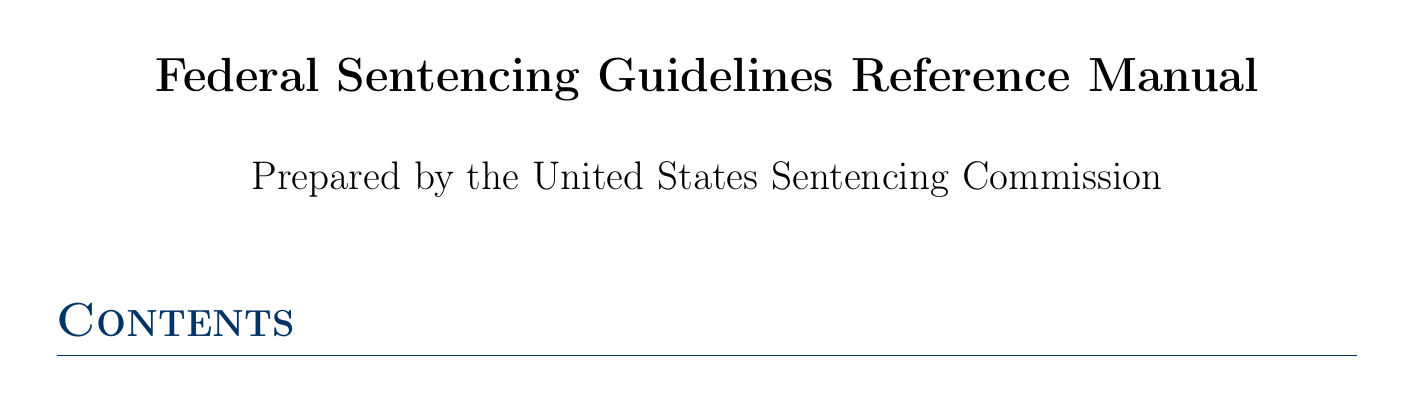What is the purpose of the Sentencing Reform Act? The purpose of the Sentencing Reform Act is detailed in the Introduction section of the document, emphasizing the establishment of guidelines for fair sentencing.
Answer: Establishment of guidelines What amendment revised the Drug Quantity Table? Amendment 782 is mentioned in the Recent Amendments section, specifically addressing changes to the Drug Quantity Table.
Answer: Amendment 782 What case impacted federal sentencing guidelines in 2005? The case of United States v. Booker is highlighted in the Circuit Court Interpretations section for its significant effect on federal sentencing.
Answer: United States v. Booker What are the grounds for departure under USSG §5K2.0? The Departure and Variance Considerations section addresses various grounds for departure as specified in the guidelines.
Answer: USSG §5K2.0 Which chapter discusses ethical considerations for judges? The Ethical Considerations for Judges section focuses on maintaining impartiality and addressing disparities in sentencing.
Answer: Ethical Considerations for Judges How many amendments are listed in the Recent Amendments section? Three amendments are specified under the Recent Amendments to the Guidelines section, detailing each one.
Answer: Three What is the primary focus of the Case Studies and Practical Applications section? This section provides illustrative examples and discussions related to complex sentencing scenarios and decisions.
Answer: Complex sentencing scenarios Which statute relates to the imposition of a sentence? The statute 18 U.S.C. § 3553 is mentioned in the Relevant Statutes section regarding the imposition of sentences.
Answer: 18 U.S.C. § 3553 Who authored the book "Federal Sentencing Law and Practice"? The book is authored by Thomas W. Hutchison and others, as listed in the Key Resources section.
Answer: Thomas W. Hutchison, David Yellen, Peter B. Hoffman, Deborah Young What does USSG §2D1.1 address? USSG §2D1.1 is discussed in the Specific Offense Characteristics section, focusing on drug trafficking enhancements.
Answer: Drug trafficking enhancements 